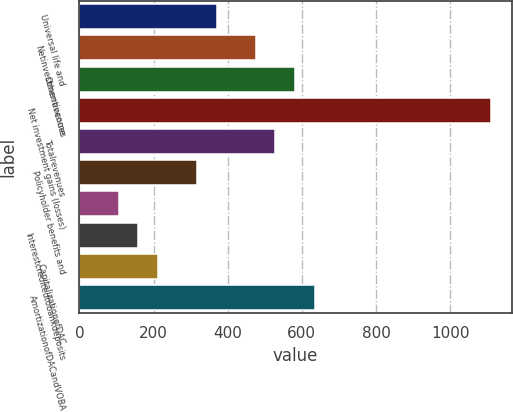<chart> <loc_0><loc_0><loc_500><loc_500><bar_chart><fcel>Universal life and<fcel>Netinvestmentincome<fcel>Otherrevenues<fcel>Net investment gains (losses)<fcel>Totalrevenues<fcel>Policyholder benefits and<fcel>Unnamed: 6<fcel>Interestcreditedtobankdeposits<fcel>CapitalizationofDAC<fcel>AmortizationofDACandVOBA<nl><fcel>370.44<fcel>476.08<fcel>581.72<fcel>1109.92<fcel>528.9<fcel>317.62<fcel>106.34<fcel>159.16<fcel>211.98<fcel>634.54<nl></chart> 